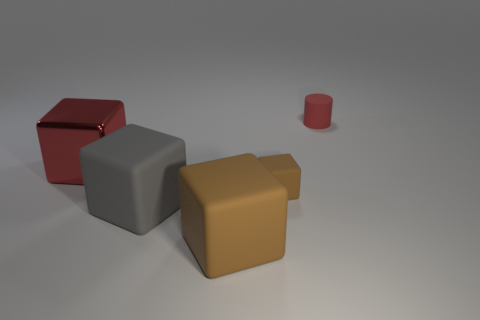Add 5 matte cylinders. How many matte cylinders exist? 6 Add 2 cylinders. How many objects exist? 7 Subtract all brown cubes. How many cubes are left? 2 Subtract all big red cubes. How many cubes are left? 3 Subtract 0 brown cylinders. How many objects are left? 5 Subtract all cubes. How many objects are left? 1 Subtract 1 cylinders. How many cylinders are left? 0 Subtract all gray cubes. Subtract all blue spheres. How many cubes are left? 3 Subtract all blue balls. How many gray blocks are left? 1 Subtract all big brown rubber cylinders. Subtract all matte things. How many objects are left? 1 